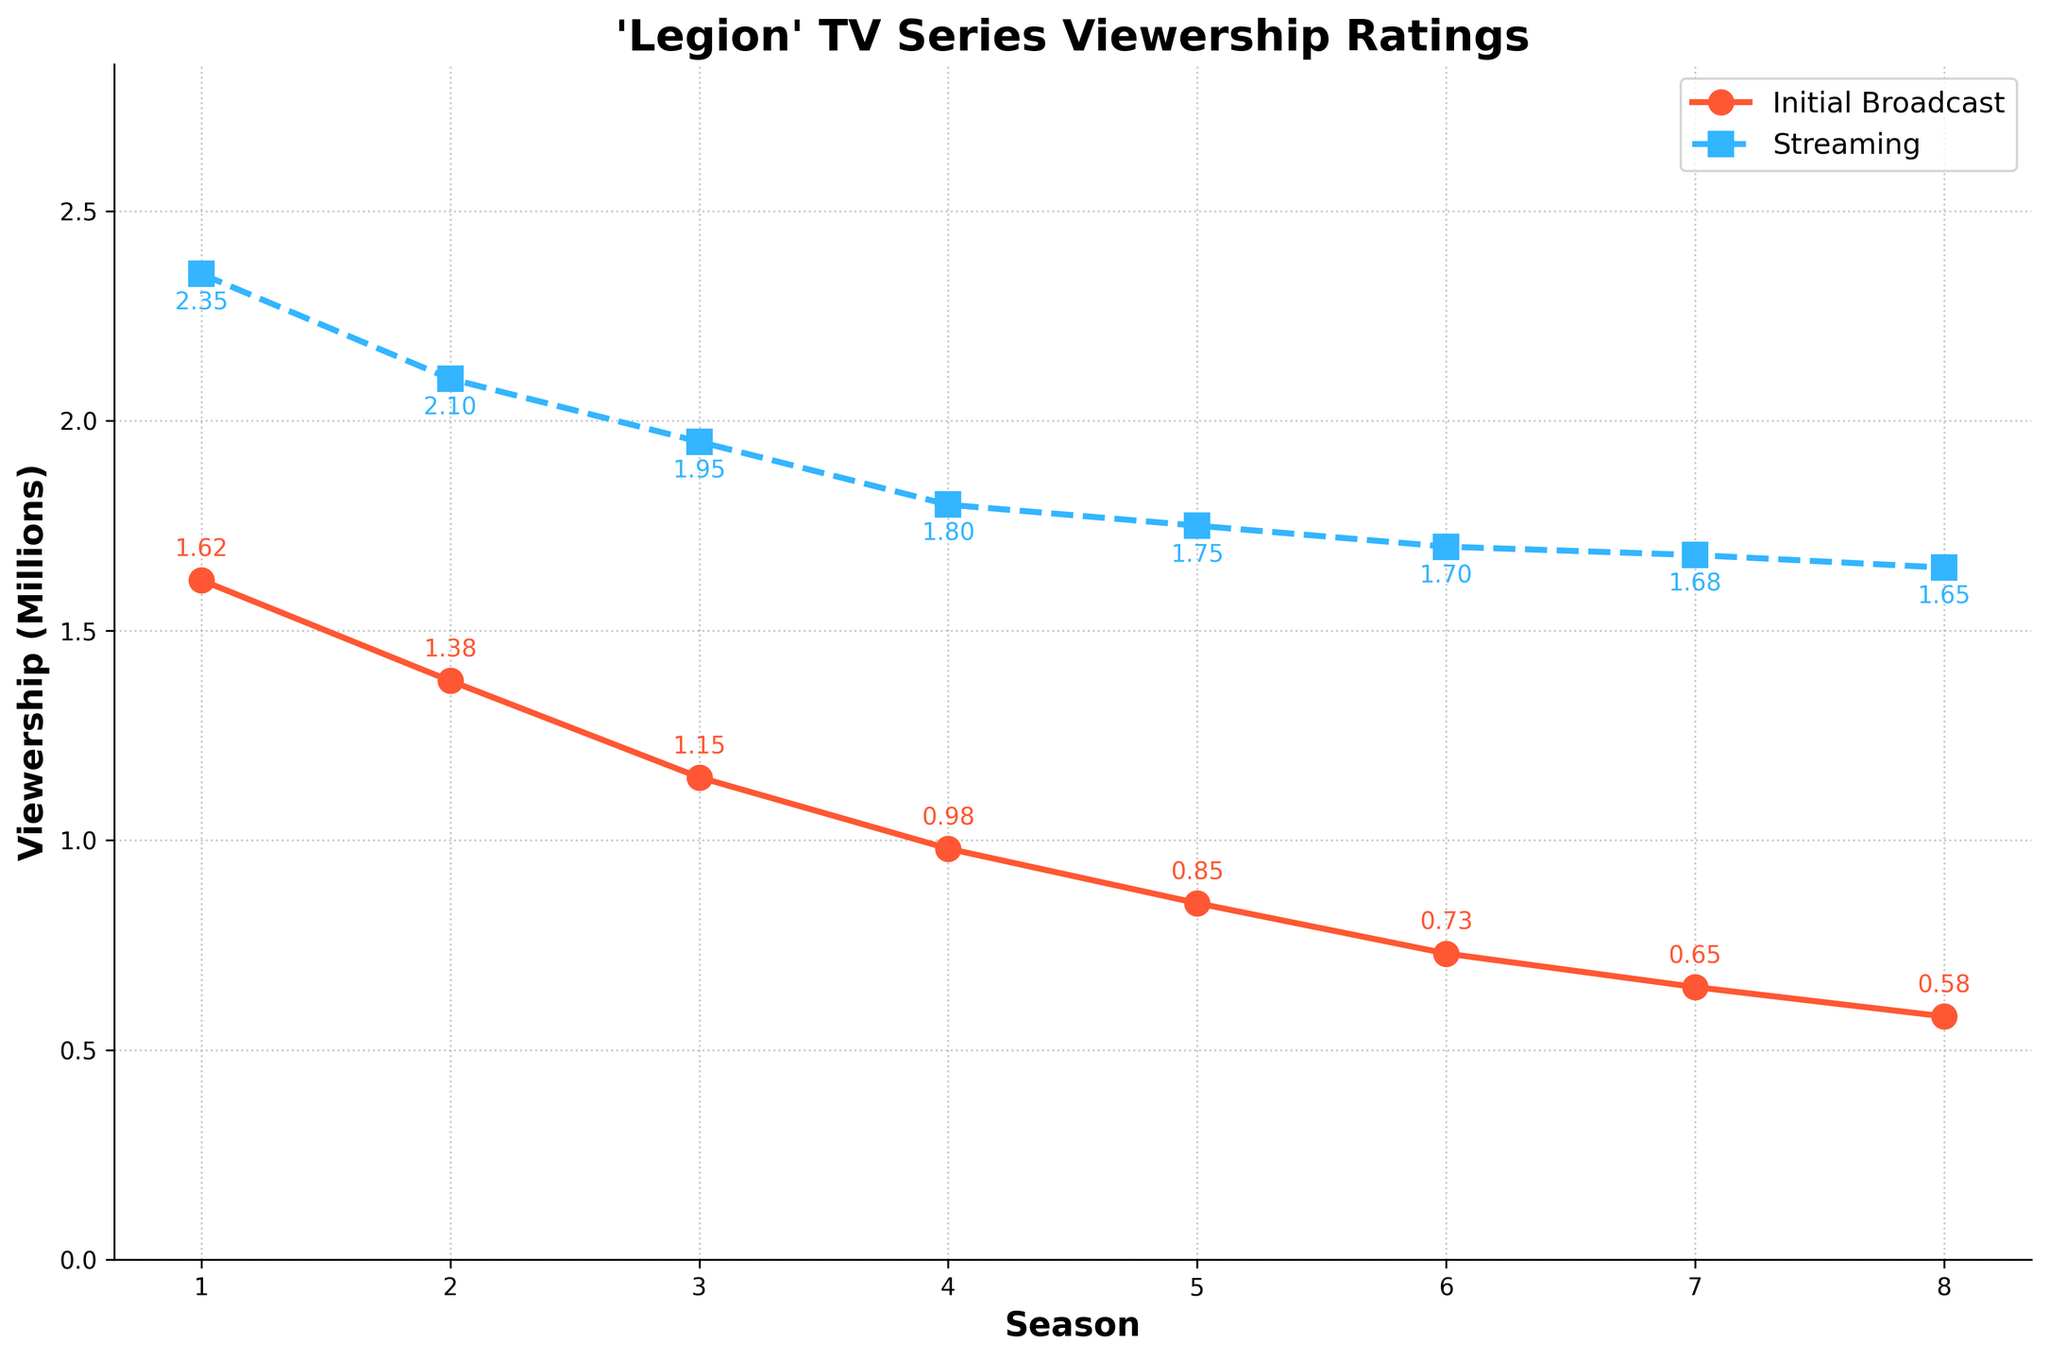What is the viewership rating for the initial broadcast for Season 1? The viewership rating for the initial broadcast is represented by the red line with a circular marker, labeled at each data point. For Season 1, the value next to the circular marker is 1.62 million.
Answer: 1.62 million How do the initial broadcast and streaming ratings compare for Season 5? To answer this, look at the data points for Season 5 on both lines. The initial broadcast (red circle) is 0.85 million, and the streaming (blue square) is 1.75 million.
Answer: Streaming is higher by 0.90 million What is the average streaming viewership over all the seasons? Sum up all the streaming numbers and then divide by the number of seasons: (2.35 + 2.10 + 1.95 + 1.80 + 1.75 + 1.70 + 1.68 + 1.65) / 8 = 1.875 million
Answer: 1.875 million Which season has the lowest initial broadcast viewership? Look at the red line and identify the lowest data point. The lowest value is at Season 8, which is 0.58 million.
Answer: Season 8 Between which two consecutive seasons is the largest drop in initial broadcast viewership? Calculate the difference in initial broadcast viewership between consecutive seasons: (1.62-1.38), (1.38-1.15), (1.15-0.98), (0.98-0.85), (0.85-0.73), (0.73-0.65), (0.65-0.58). The largest drop is between Season 1 and Season 2 with a difference of 0.24 million.
Answer: Between Season 1 and Season 2 Is there any season where streaming viewership is equal to twice the initial broadcast viewership? Compare streaming viewership to twice the initial broadcast viewership for each season. For instance, Season 1: 2.35 vs. 2*1.62 = 3.24. None of these comparisons equal each other.
Answer: No During which season does the gap between streaming and initial broadcast viewership widen the most? Calculate the streaming-initial broadcast gap for each season: (2.35-1.62), (2.10-1.38), (1.95-1.15), (1.80-0.98), (1.75-0.85), (1.70-0.73), (1.68-0.65), (1.65-0.58). The gap is widest during Season 1 (0.73 million).
Answer: Season 1 How much did the initial broadcast viewership decline from Season 3 to Season 7? Subtract the initial broadcast viewership of Season 7 from Season 3: 1.15 - 0.65 = 0.50 million.
Answer: 0.50 million Is the streaming viewership consistently higher than the initial broadcast viewership across all seasons? Compare the streaming and initial broadcast viewership for each season. In every season, the streaming (blue line) is higher than the initial broadcast (red line).
Answer: Yes 